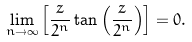Convert formula to latex. <formula><loc_0><loc_0><loc_500><loc_500>\lim _ { n \rightarrow \infty } \left [ \frac { z } { 2 ^ { n } } \tan \left ( \frac { z } { 2 ^ { n } } \right ) \right ] = 0 .</formula> 